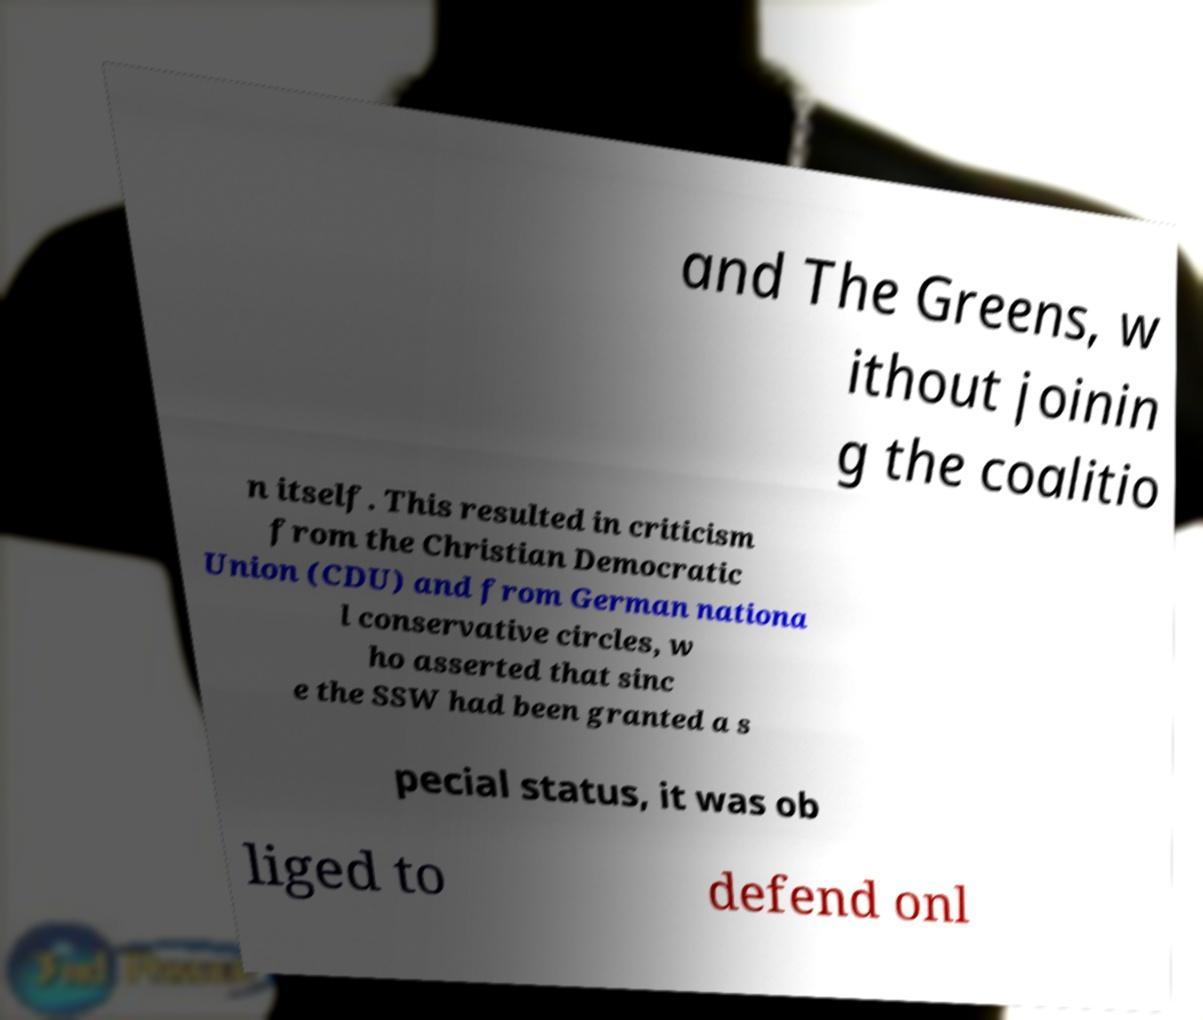Please read and relay the text visible in this image. What does it say? and The Greens, w ithout joinin g the coalitio n itself. This resulted in criticism from the Christian Democratic Union (CDU) and from German nationa l conservative circles, w ho asserted that sinc e the SSW had been granted a s pecial status, it was ob liged to defend onl 